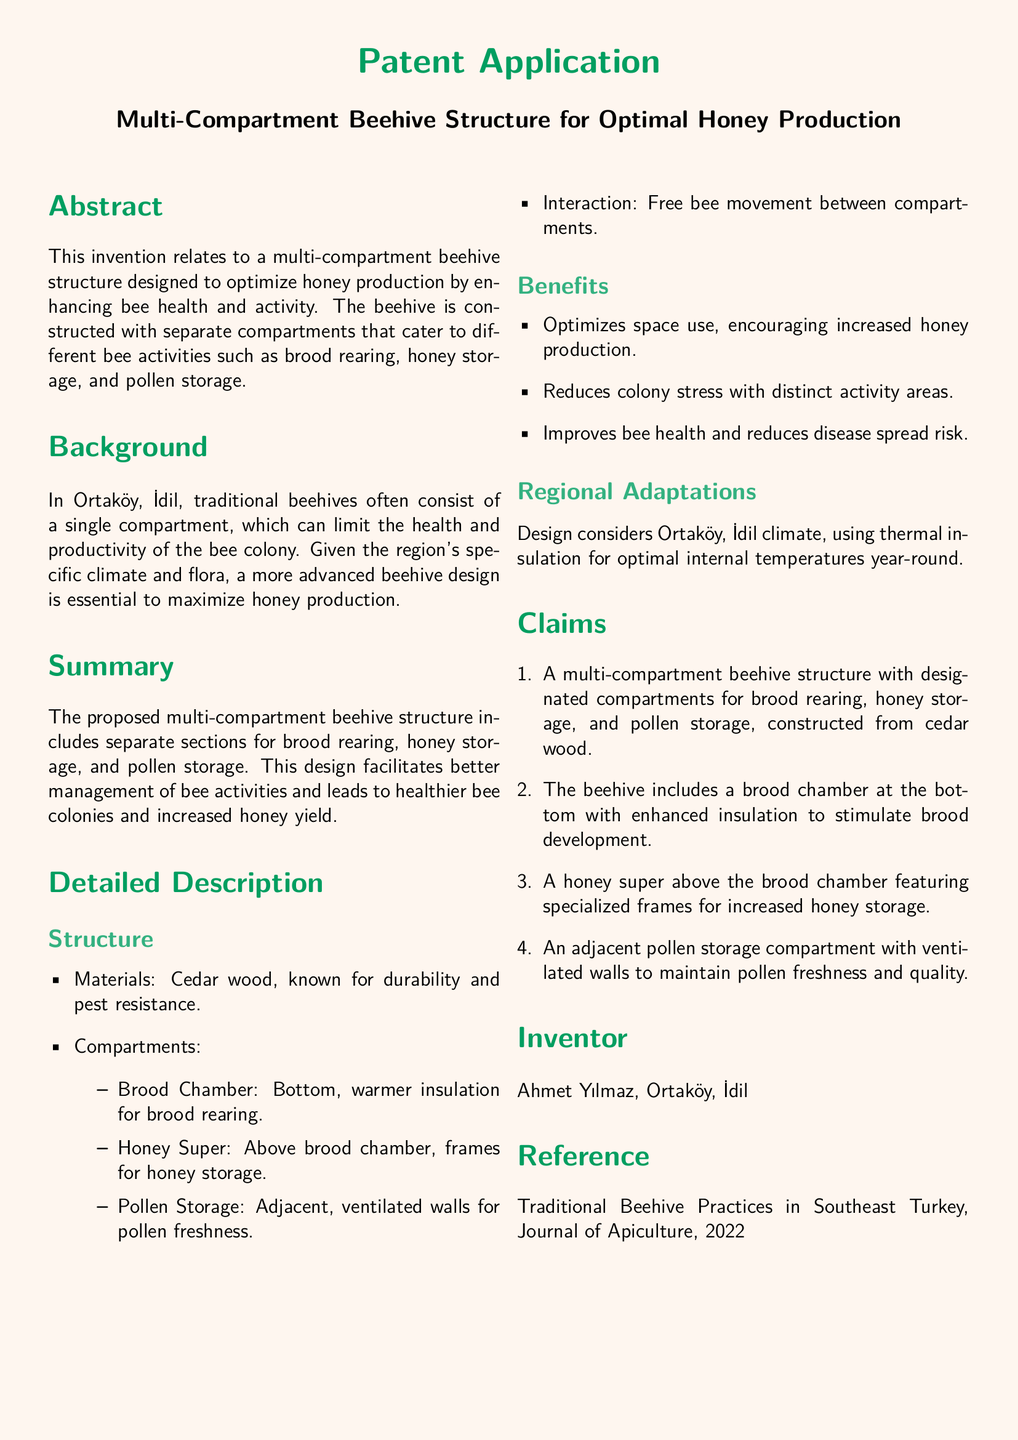What is the invention related to? The invention relates to a multi-compartment beehive structure designed to optimize honey production by enhancing bee health and activity.
Answer: Multi-compartment beehive structure Who is the inventor? The document lists the name of the inventor at the end, highlighting their contribution to the invention.
Answer: Ahmet Yılmaz What material is the beehive constructed from? The document specifies the primary material used for constructing the beehive, known for its durability.
Answer: Cedar wood What is the purpose of the brood chamber? The beehive structure describes the purpose of the brood chamber and its significance in bee activities.
Answer: Brood rearing What year was the reference article published? The reference section of the document includes a publication year for the cited article.
Answer: 2022 What are the types of compartments mentioned? The document lists specific types of compartments designed for various bee activities.
Answer: Brood chamber, honey super, pollen storage How does the design benefit bee health? The benefits section highlights how the beehive structure aids in the overall health of bees.
Answer: Reduces colony stress Why is the beehive designed for Ortaköy, İdil? The background section mentions the emphasis on the local climate and conditions in the design process.
Answer: Regional climate adaptation 